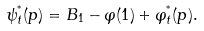Convert formula to latex. <formula><loc_0><loc_0><loc_500><loc_500>\psi ^ { ^ { * } } _ { t } ( p ) = B _ { 1 } - \varphi ( 1 ) + \varphi ^ { ^ { * } } _ { t } ( p ) .</formula> 